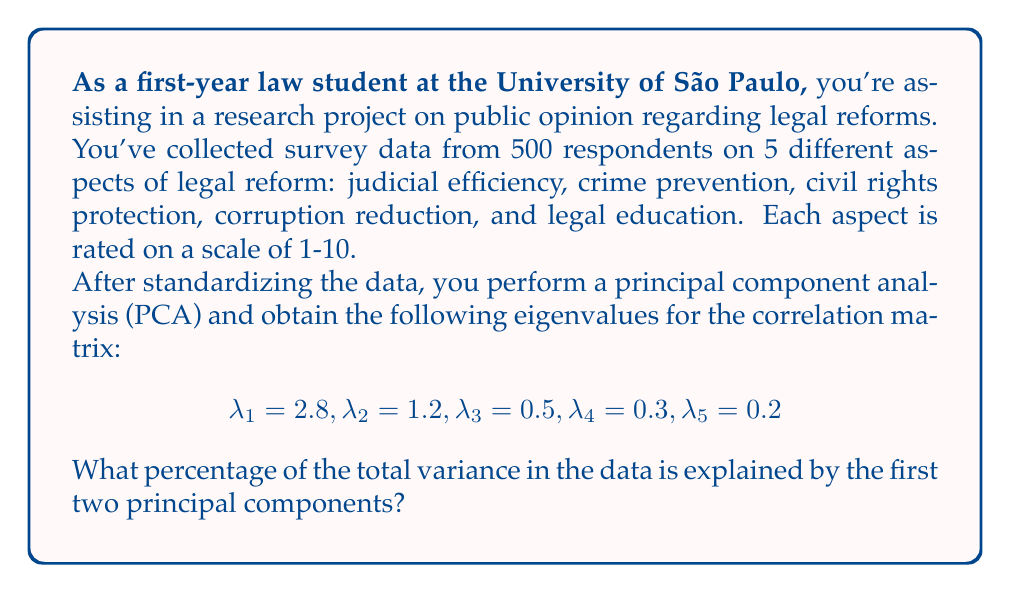Teach me how to tackle this problem. To solve this problem, we'll follow these steps:

1) First, recall that in PCA, each eigenvalue represents the amount of variance explained by its corresponding principal component.

2) The total variance in a standardized dataset is equal to the number of variables. In this case, we have 5 variables, so the total variance is 5.

3) To calculate the percentage of variance explained by the first two principal components, we need to:
   a) Sum the eigenvalues of the first two components
   b) Divide this sum by the total variance
   c) Multiply by 100 to get the percentage

4) Let's perform these calculations:

   a) Sum of first two eigenvalues:
      $\lambda_1 + \lambda_2 = 2.8 + 1.2 = 4$

   b) Divide by total variance:
      $\frac{4}{5} = 0.8$

   c) Convert to percentage:
      $0.8 \times 100 = 80\%$

Therefore, the first two principal components explain 80% of the total variance in the data.
Answer: 80% 